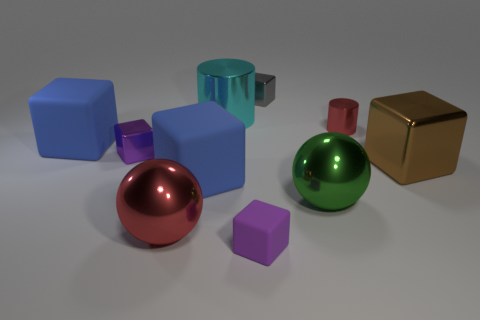Subtract all blue cubes. How many cubes are left? 4 Subtract 3 blocks. How many blocks are left? 3 Subtract all small gray metal blocks. How many blocks are left? 5 Subtract all yellow cubes. Subtract all brown spheres. How many cubes are left? 6 Subtract all cylinders. How many objects are left? 8 Add 7 purple metallic things. How many purple metallic things exist? 8 Subtract 0 red cubes. How many objects are left? 10 Subtract all green shiny objects. Subtract all small metal objects. How many objects are left? 6 Add 2 large blue blocks. How many large blue blocks are left? 4 